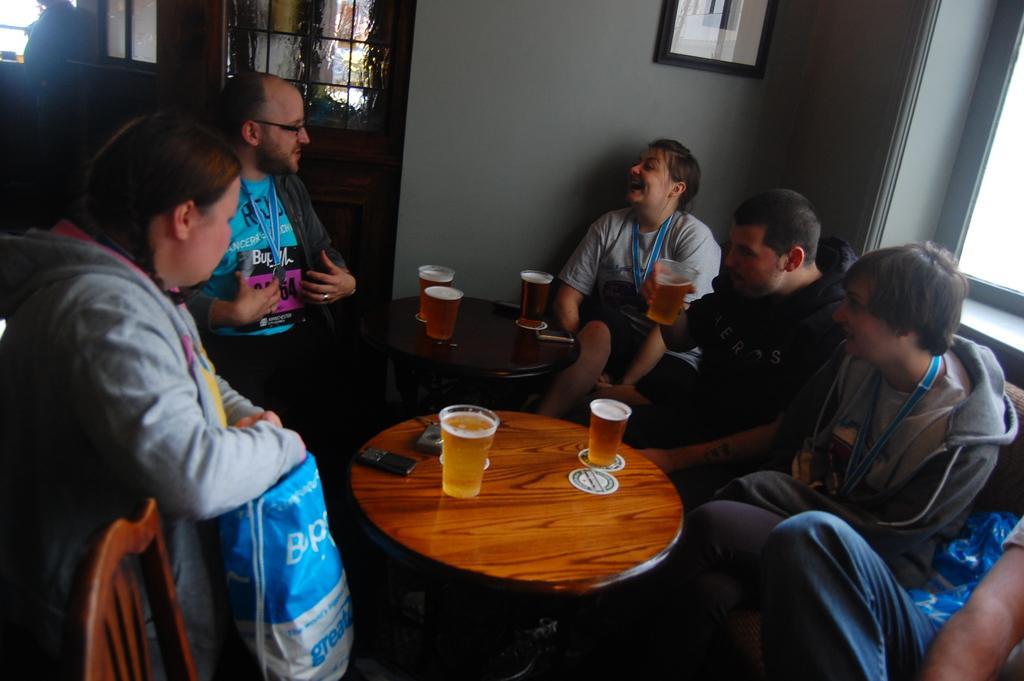Describe this image in one or two sentences. In this image there are group of people who are sitting and in the center there are two tables on the table there are some glasses and that glasses are filled with drinks and on the top there is wall. On the wall there is one photo frame and on the right side there is a window and on the left side there is s a door. 